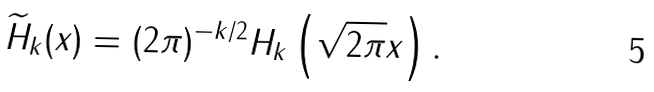<formula> <loc_0><loc_0><loc_500><loc_500>\widetilde { H } _ { k } ( x ) = ( 2 \pi ) ^ { - k / 2 } H _ { k } \left ( \sqrt { 2 \pi } x \right ) .</formula> 